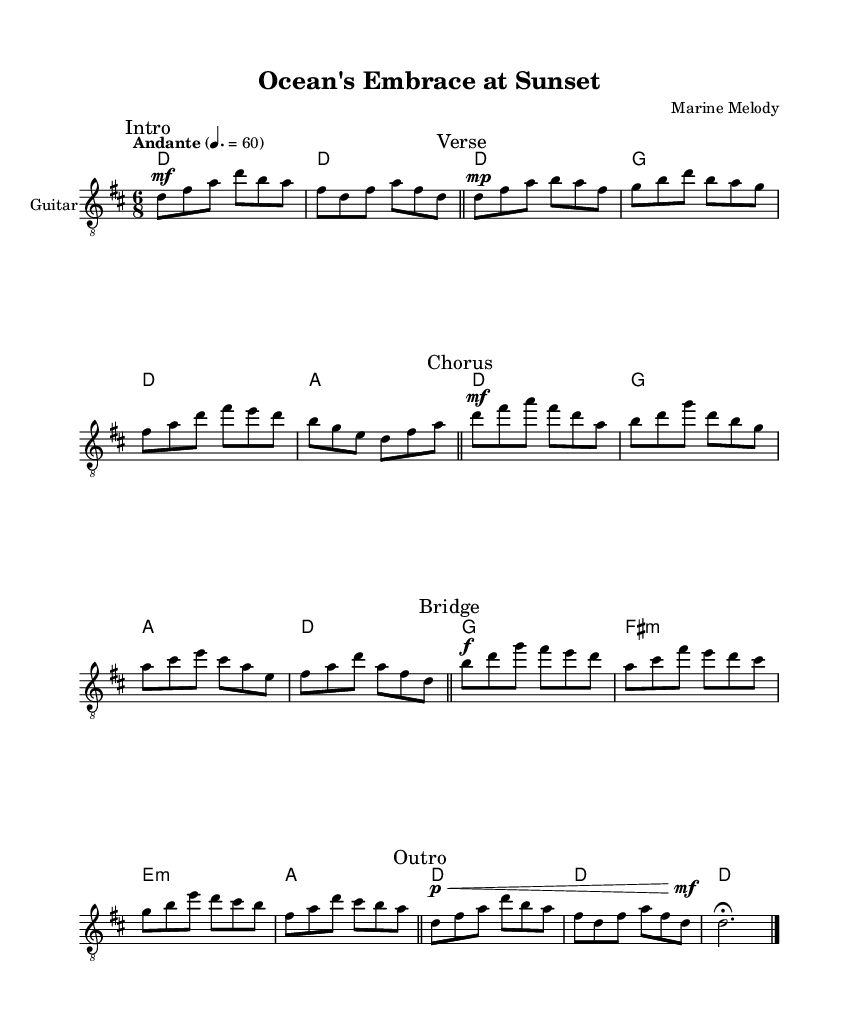What is the key signature of this music? The key signature is D major, which has two sharps (F# and C#). This can be recognized by looking at the key signature indicated at the beginning of the staff.
Answer: D major What is the time signature of this piece? The time signature is 6/8, which can be identified by the symbol located at the beginning of the staff as it denotes a compound time signature commonly used for waltz-like rhythms.
Answer: 6/8 What tempo marking is indicated in the music? The tempo marking is "Andante," which is a common term that indicates a moderately slow tempo. This can be found next to the tempo marking above the musical notes.
Answer: Andante What type of harmonies are used in the piece? The piece predominantly uses triad chords, recognized by looking at the chord symbols written above the staff. Each set of notes corresponds to the harmonic structure typically found in romantic music.
Answer: Triad chords How many sections are there in the song? The song consists of five sections: intro, verse, chorus, bridge, and outro. The various markings such as "Intro," "Verse," etc., define these distinct sections within the music.
Answer: Five sections What dynamic markings are present in the music? The dynamic markings include "mf," "mp," "f," and "p," which indicate the varying levels of loudness throughout the piece. Looking at the score, these are placed before specific notes throughout the sections.
Answer: mf, mp, f, p Which musical instrument is indicated for the performance of this piece? The score specifies "Guitar," explicitly written within the instrument designation at the beginning of the staff, showcasing that the piece is arranged for guitar performance.
Answer: Guitar 